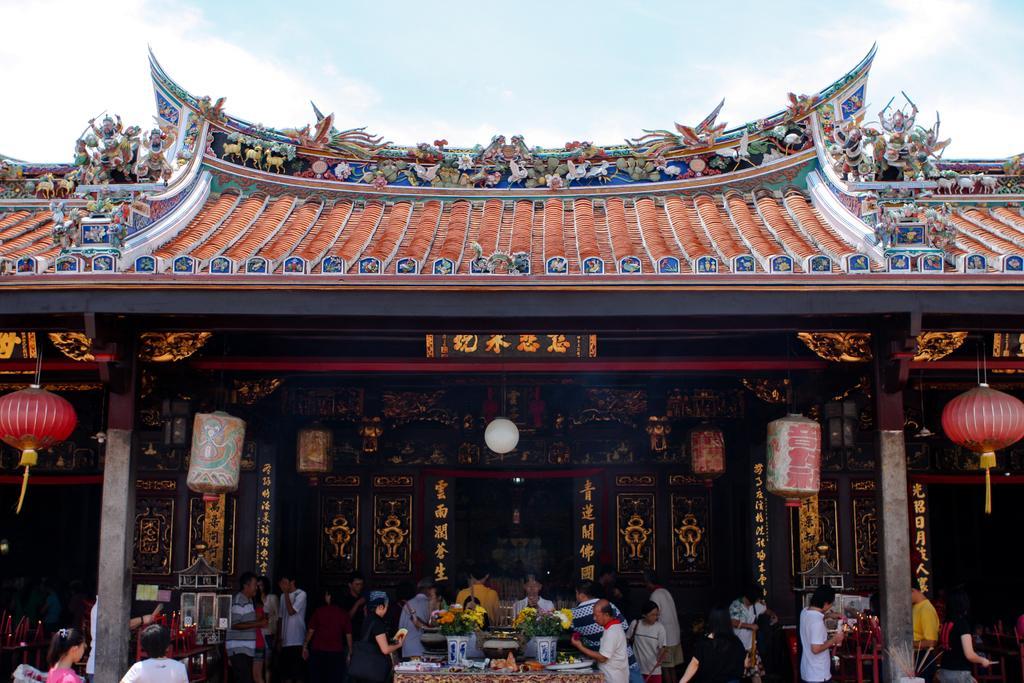Can you describe this image briefly? In this image I can see number of persons are standing, a table and on the table I can see few flowers vases with plants and flowers in them and few other objects. I can see few lanterns, a building, the roof of the building and something is written on the building with gold color. I can see the sky in the background. 